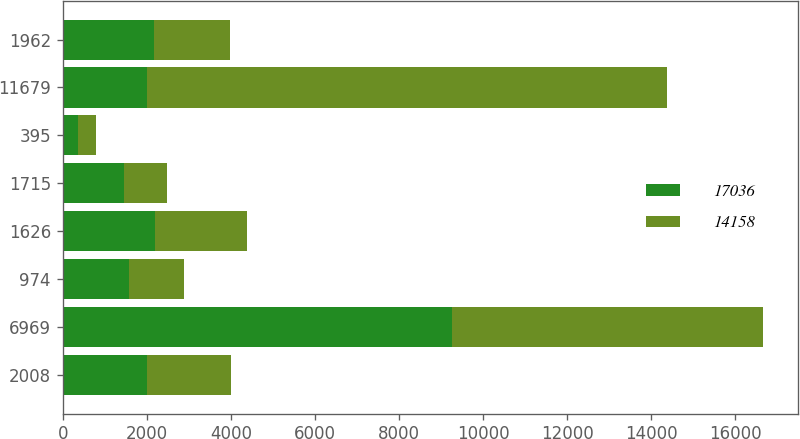Convert chart. <chart><loc_0><loc_0><loc_500><loc_500><stacked_bar_chart><ecel><fcel>2008<fcel>6969<fcel>974<fcel>1626<fcel>1715<fcel>395<fcel>11679<fcel>1962<nl><fcel>17036<fcel>2007<fcel>9260<fcel>1582<fcel>2186<fcel>1457<fcel>368<fcel>2006<fcel>2183<nl><fcel>14158<fcel>2006<fcel>7410<fcel>1300<fcel>2192<fcel>1027<fcel>436<fcel>12365<fcel>1793<nl></chart> 